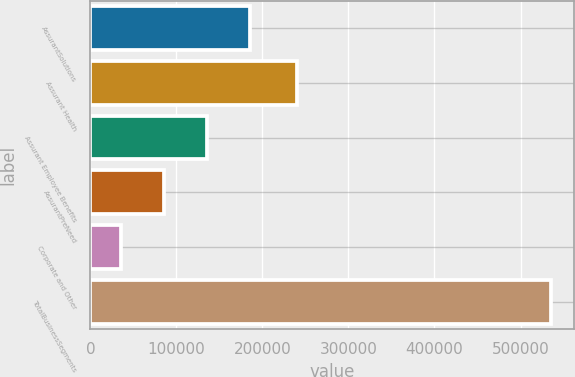Convert chart. <chart><loc_0><loc_0><loc_500><loc_500><bar_chart><fcel>AssurantSolutions<fcel>Assurant Health<fcel>Assurant Employee Benefits<fcel>AssurantPreNeed<fcel>Corporate and Other<fcel>TotalBusinessSegments<nl><fcel>185317<fcel>240218<fcel>135230<fcel>85142.3<fcel>35055<fcel>535928<nl></chart> 